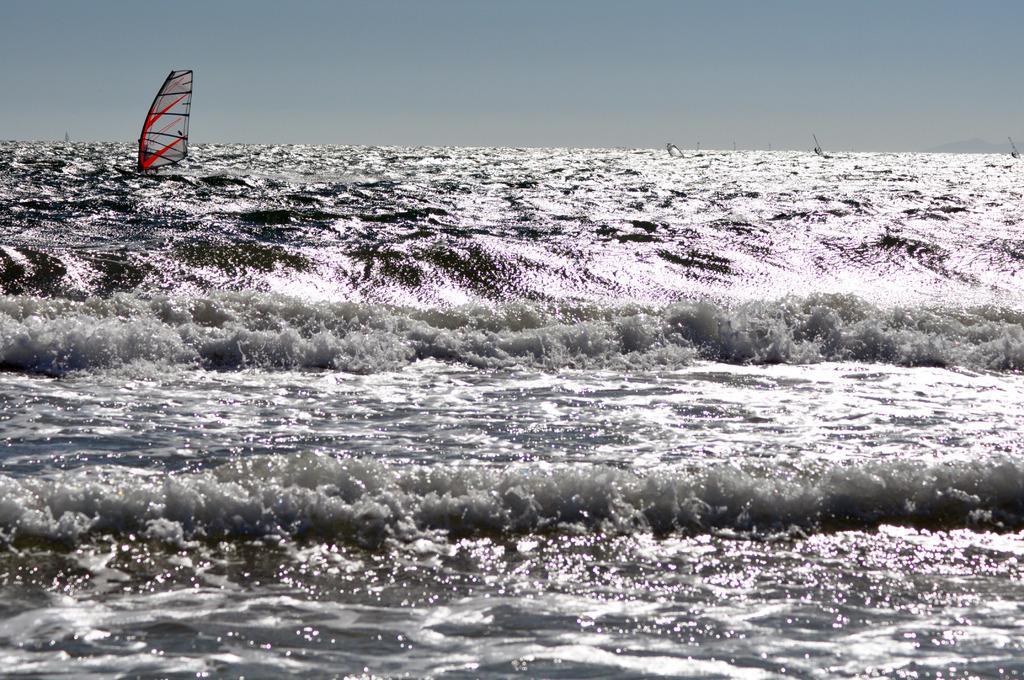What is the main element in the image? There is water in the image. What can be seen floating in the water? There is an object in the water that looks like a boat. What is visible in the background of the image? The sky is visible in the background of the image. What type of collar can be seen on the boat in the image? There is no collar present on the boat in the image. Is there any visible wound on the boat in the image? There is no wound present on the boat in the image. 